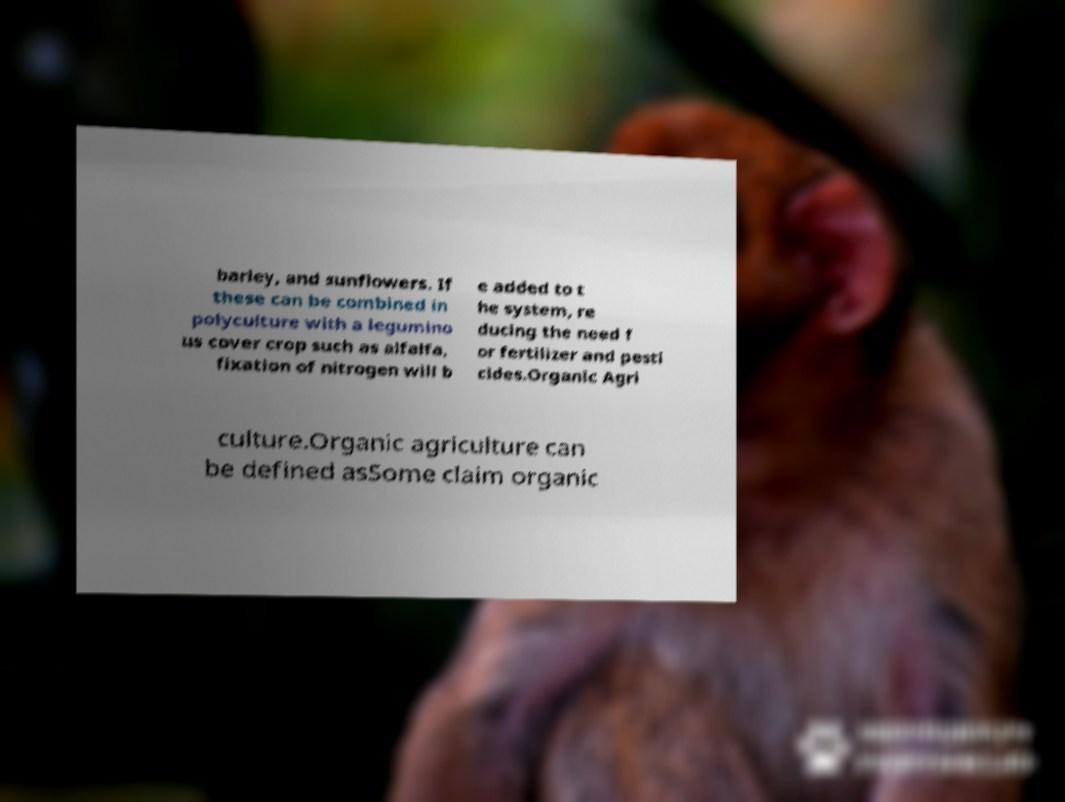Could you extract and type out the text from this image? barley, and sunflowers. If these can be combined in polyculture with a legumino us cover crop such as alfalfa, fixation of nitrogen will b e added to t he system, re ducing the need f or fertilizer and pesti cides.Organic Agri culture.Organic agriculture can be defined asSome claim organic 